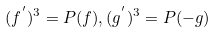Convert formula to latex. <formula><loc_0><loc_0><loc_500><loc_500>( f ^ { ^ { \prime } } ) ^ { 3 } = P ( f ) , ( g ^ { ^ { \prime } } ) ^ { 3 } = P ( - g )</formula> 